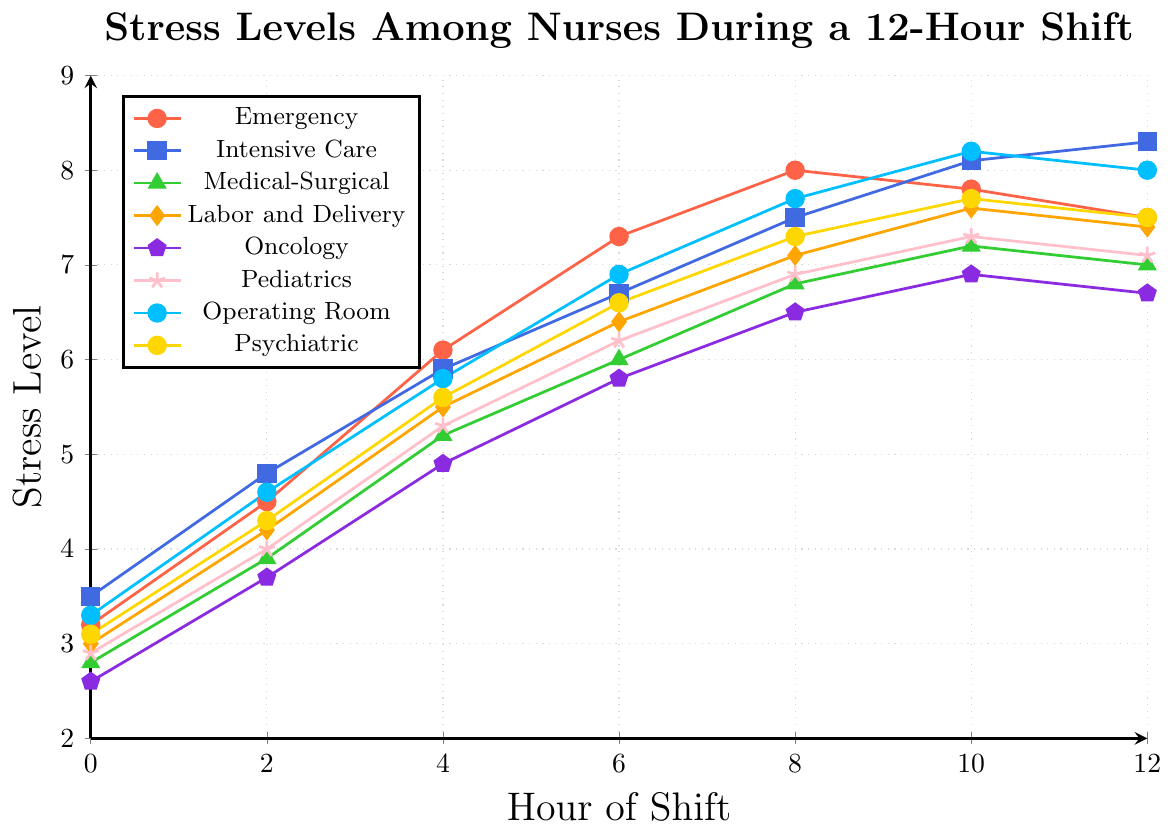Which department has the highest stress level at Hour 12? By looking at the data points at Hour 12, we compare all departments' stress levels. Intensive Care has a stress level of 8.3, which is the highest.
Answer: Intensive Care What is the difference in stress levels between the Emergency and Operating Room departments at Hour 8? At Hour 8, the stress level for Emergency is 8.0, and for Operating Room is 7.7. Subtracting these, 8.0 - 7.7 = 0.3.
Answer: 0.3 How does the stress level in the Pediatrics department change from Hour 0 to Hour 12? At Hour 0, the Pediatrics stress level is 2.9, and at Hour 12, it is 7.1. The change is 7.1 - 2.9 = 4.2.
Answer: 4.2 Which department shows the least increase in stress levels from Hour 0 to Hour 6? By calculating the increase for each department from Hour 0 to Hour 6, Oncology starts at 2.6 and rises to 5.8, an increase of 5.8 - 2.6 = 3.2, which is the least among all departments.
Answer: Oncology At which hour does the Labor and Delivery department have the highest stress level, and what is the value? By examining the stress levels for Labor and Delivery, the highest level is 7.6 at Hour 10.
Answer: Hour 10, 7.6 What is the overall trend of stress levels in the Intensive Care department over the 12-hour shift? The stress levels in Intensive Care rise continuously from 3.5 at Hour 0 to 8.3 at Hour 12, indicating a steady increase throughout the shift.
Answer: Steady increase How does the stress level in the Psychiatric department at Hour 4 compare to the Medical-Surgical department at the same hour? At Hour 4, the Psychiatric department has a stress level of 5.6, and the Medical-Surgical department has a stress level of 5.2. Comparing these, 5.6 > 5.2.
Answer: Higher What is the average stress level across all departments at Hour 6? Adding the stress levels at Hour 6 for all departments: 7.3 (Emergency) + 6.7 (Intensive Care) + 6.0 (Medical-Surgical) + 6.4 (Labor and Delivery) + 5.8 (Oncology) + 6.2 (Pediatrics) + 6.9 (Operating Room) + 6.6 (Psychiatric) = 52.9. Dividing by 8 departments, 52.9 / 8 = 6.6125.
Answer: 6.6125 What is the total increase in stress level in the Oncology department from Hour 0 to Hour 12? The stress level in Oncology at Hour 0 is 2.6 and at Hour 12 is 6.7. The total increase is 6.7 - 2.6 = 4.1.
Answer: 4.1 